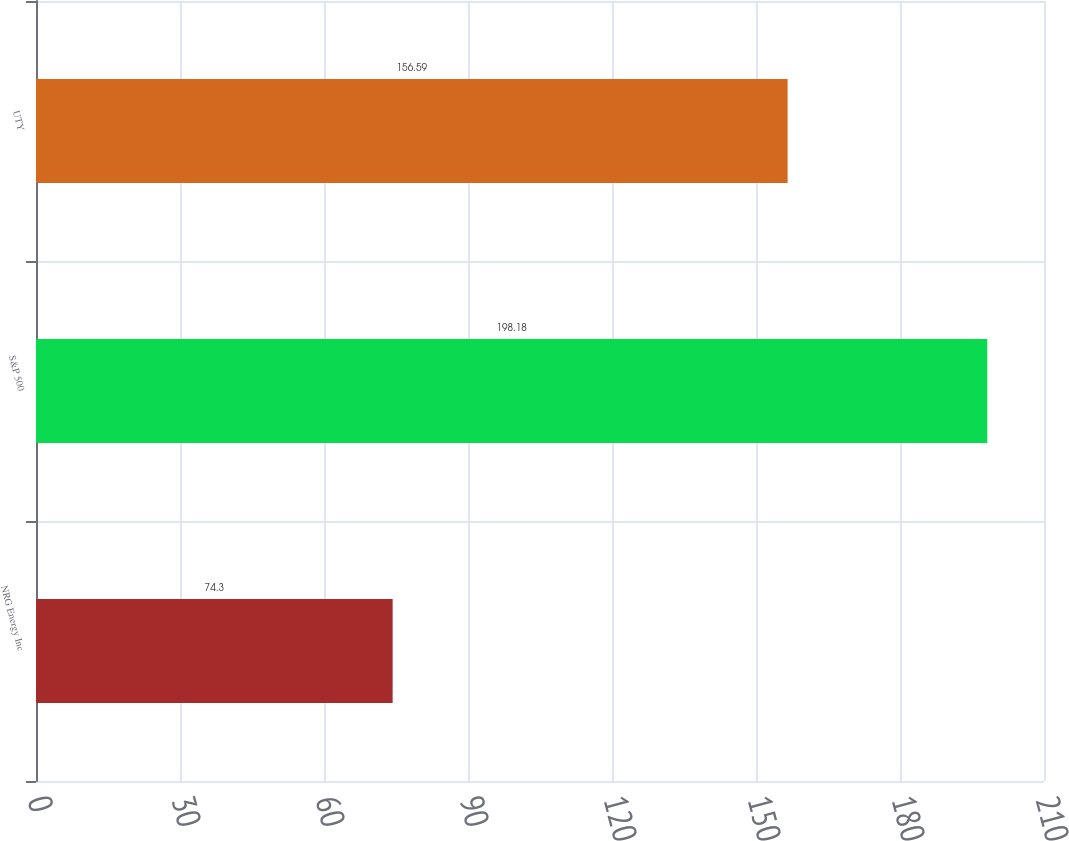<chart> <loc_0><loc_0><loc_500><loc_500><bar_chart><fcel>NRG Energy Inc<fcel>S&P 500<fcel>UTY<nl><fcel>74.3<fcel>198.18<fcel>156.59<nl></chart> 